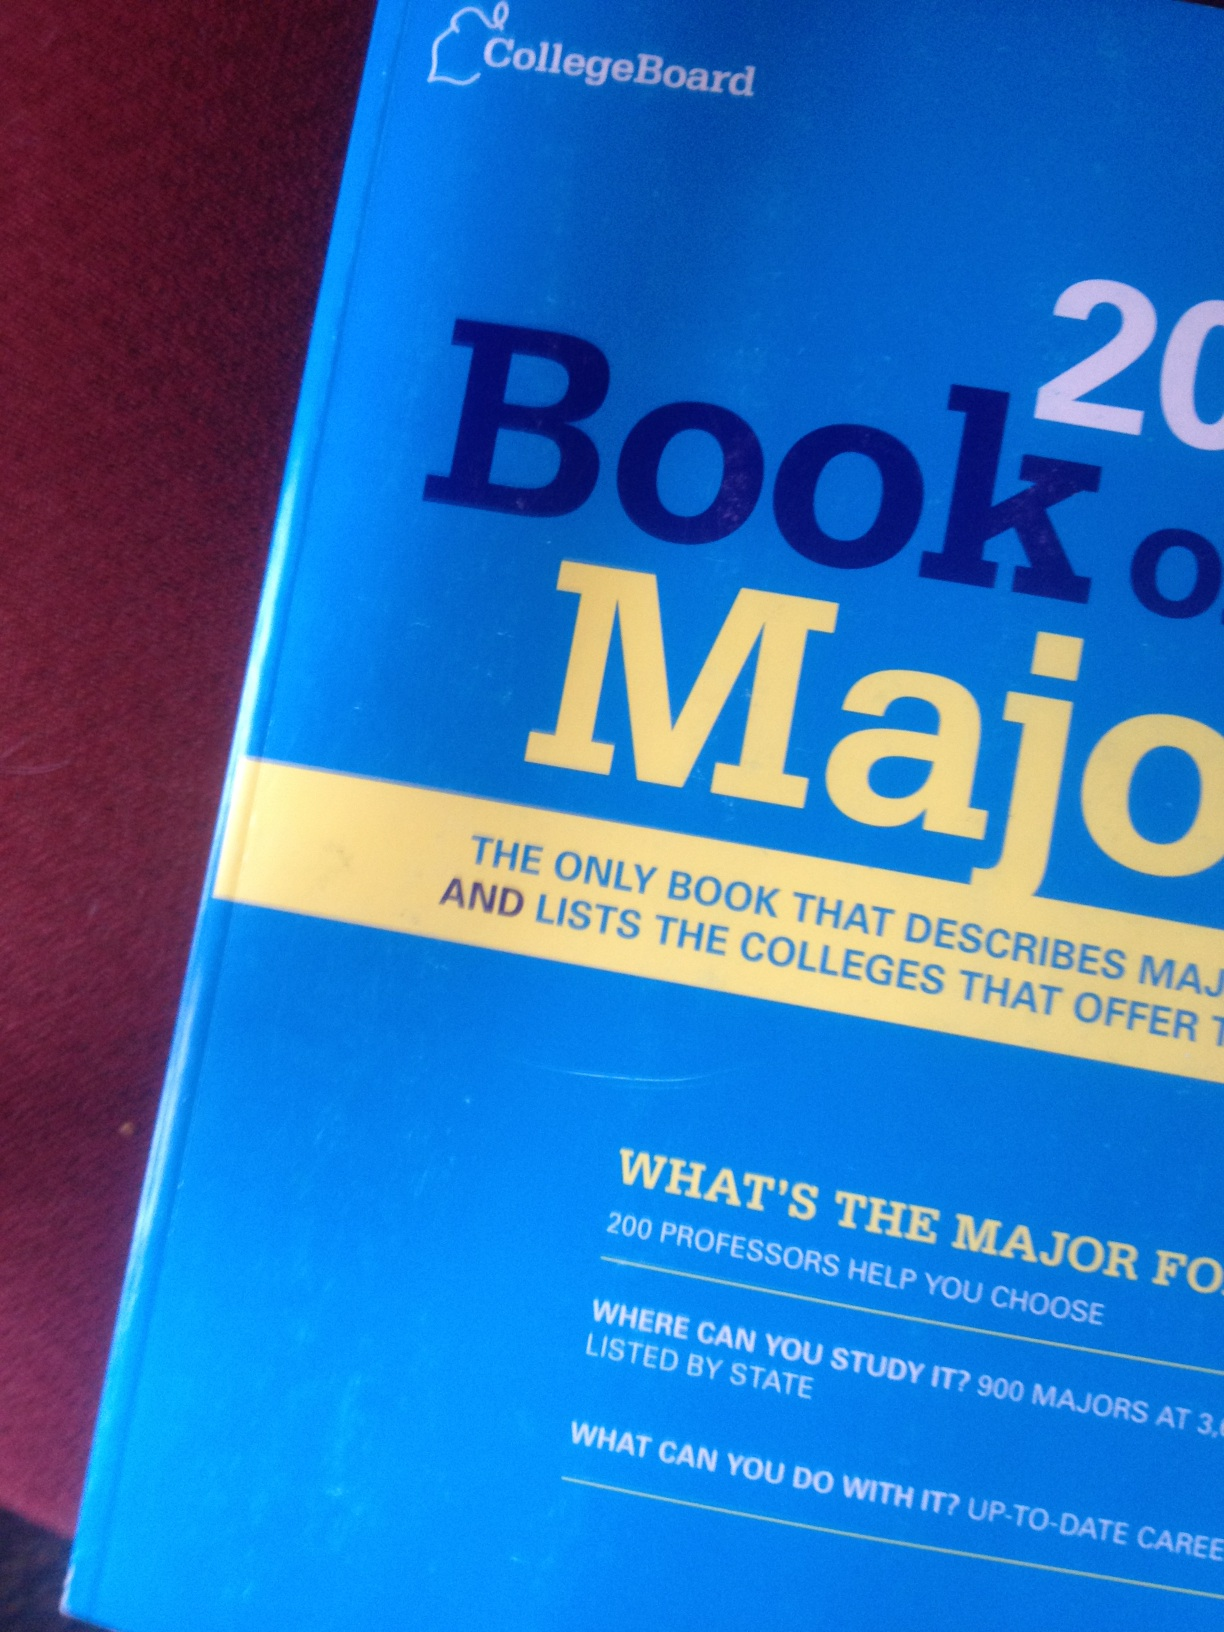What book is this? What is the title of this book? The book shown in the image is the 'Book of Majors' by CollegeBoard. It's a guide that lists various college majors and related information, including potential career paths, study locations, and advice from professors. 